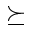Convert formula to latex. <formula><loc_0><loc_0><loc_500><loc_500>\succeq</formula> 